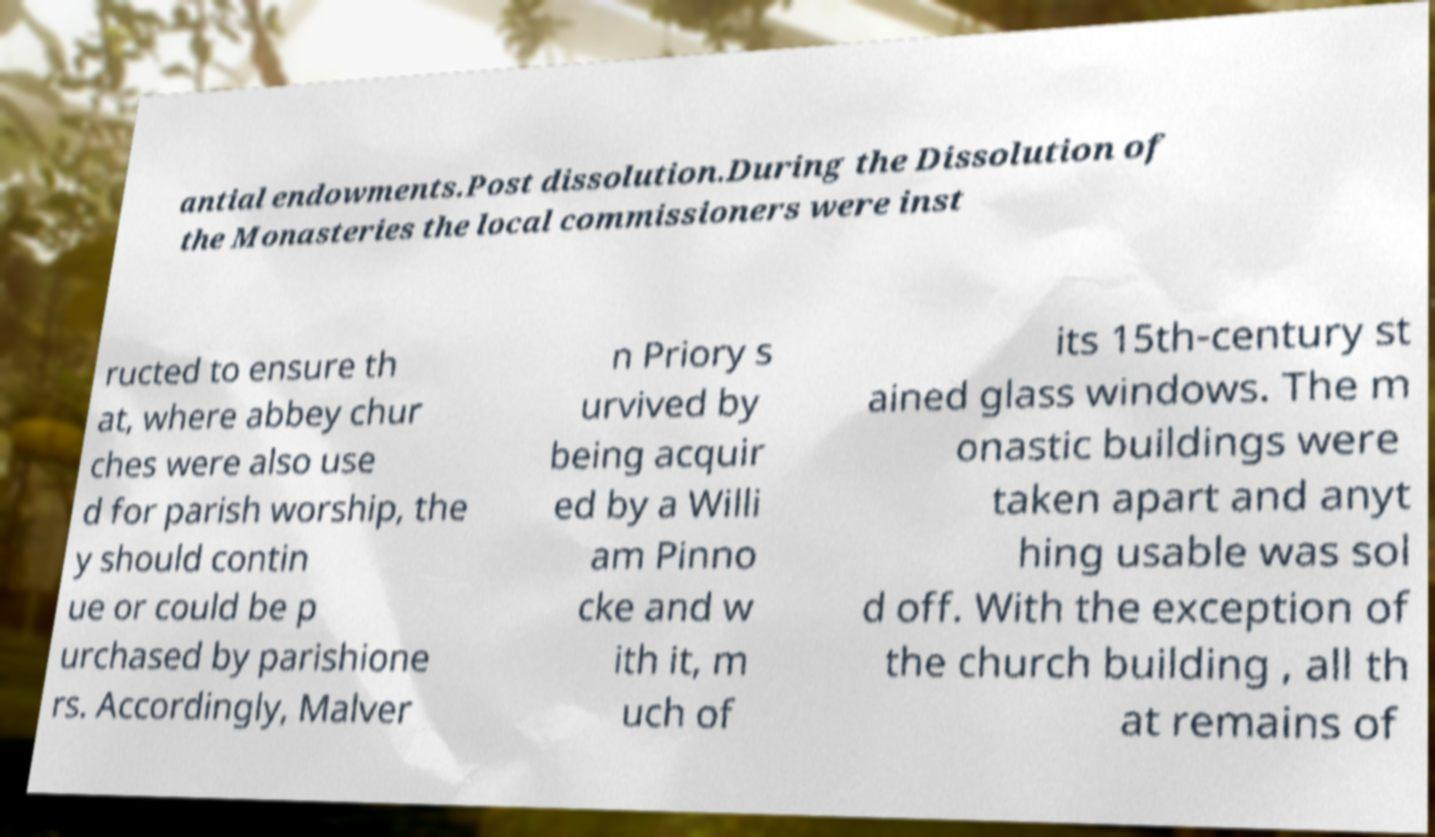Could you assist in decoding the text presented in this image and type it out clearly? antial endowments.Post dissolution.During the Dissolution of the Monasteries the local commissioners were inst ructed to ensure th at, where abbey chur ches were also use d for parish worship, the y should contin ue or could be p urchased by parishione rs. Accordingly, Malver n Priory s urvived by being acquir ed by a Willi am Pinno cke and w ith it, m uch of its 15th-century st ained glass windows. The m onastic buildings were taken apart and anyt hing usable was sol d off. With the exception of the church building , all th at remains of 